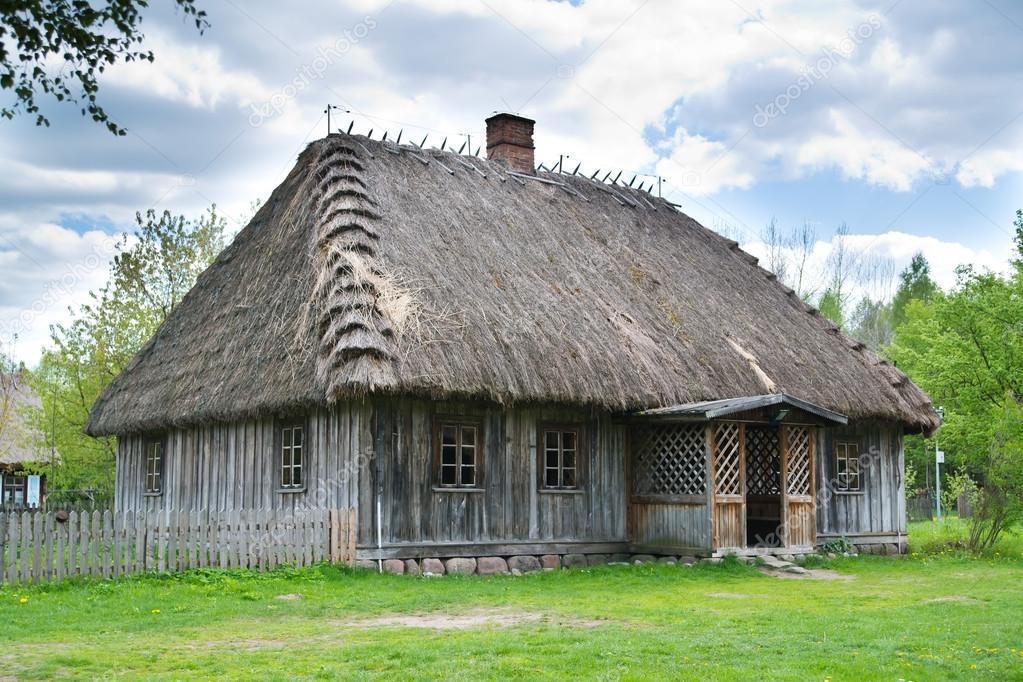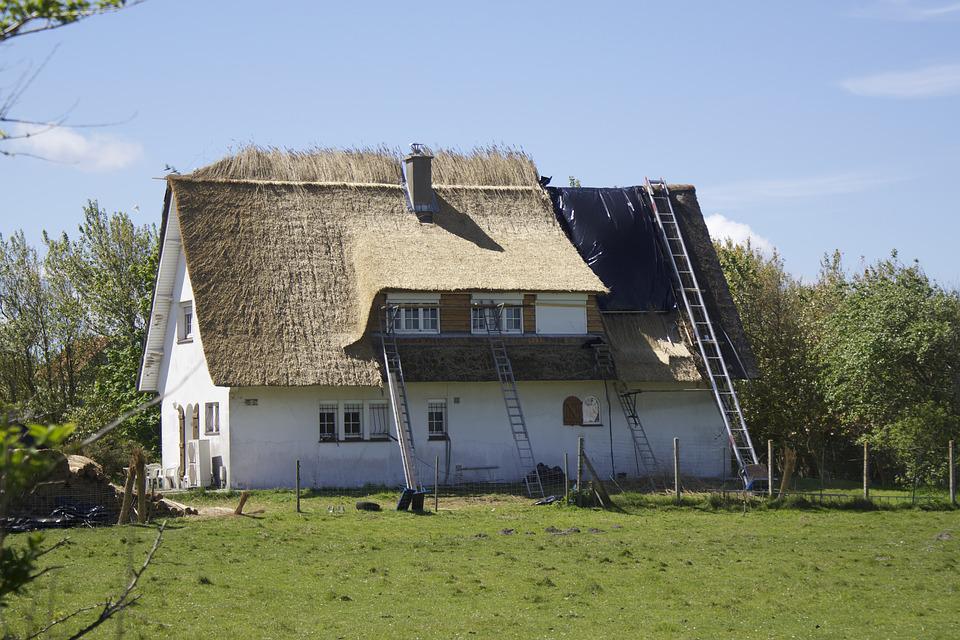The first image is the image on the left, the second image is the image on the right. Evaluate the accuracy of this statement regarding the images: "In at least one image  there is a white home with three windows and at least three triangle roof peaks.". Is it true? Answer yes or no. Yes. 